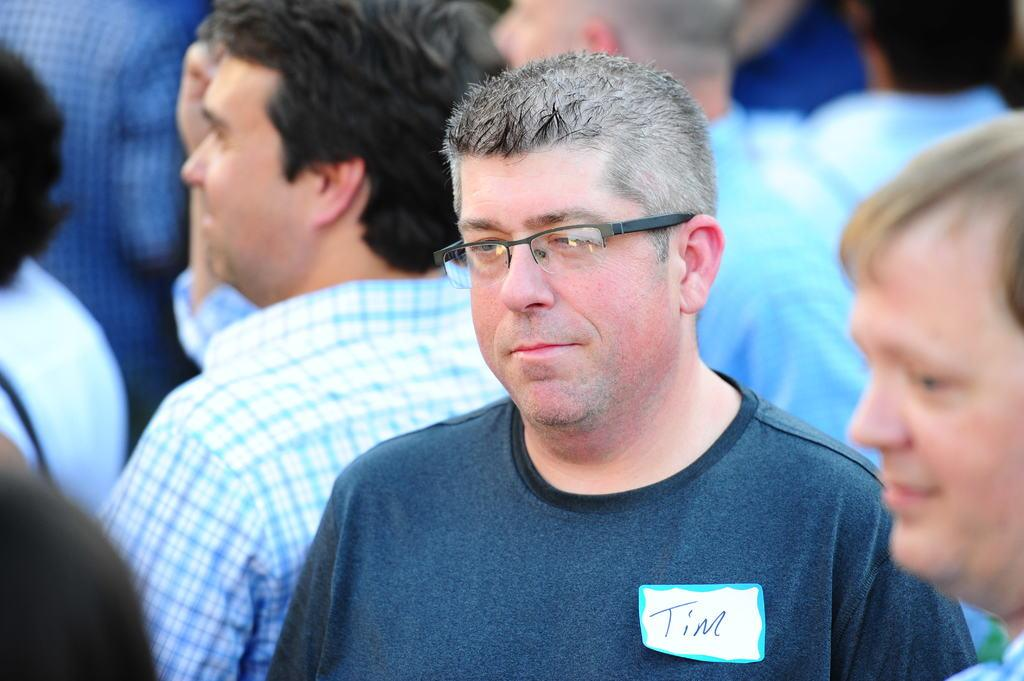What can be seen in the image? There are people in the image. Can you describe the man in the center of the image? A man is standing in the center of the image. What is the man wearing? The man is wearing glasses. What type of voyage is the man embarking on in the image? There is no indication of a voyage in the image; it simply shows a man standing in the center wearing glasses. Can you see any sand in the image? There is no sand visible in the image. 